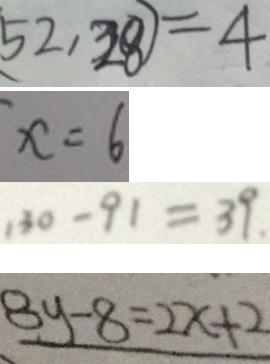<formula> <loc_0><loc_0><loc_500><loc_500>5 2 , 2 8 ) = 4 
 x = 6 
 1 3 0 - 9 1 = 3 9 . 
 8 y - 8 = 2 x + 2</formula> 